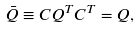Convert formula to latex. <formula><loc_0><loc_0><loc_500><loc_500>\bar { Q } \equiv C Q ^ { T } C ^ { T } = Q ,</formula> 